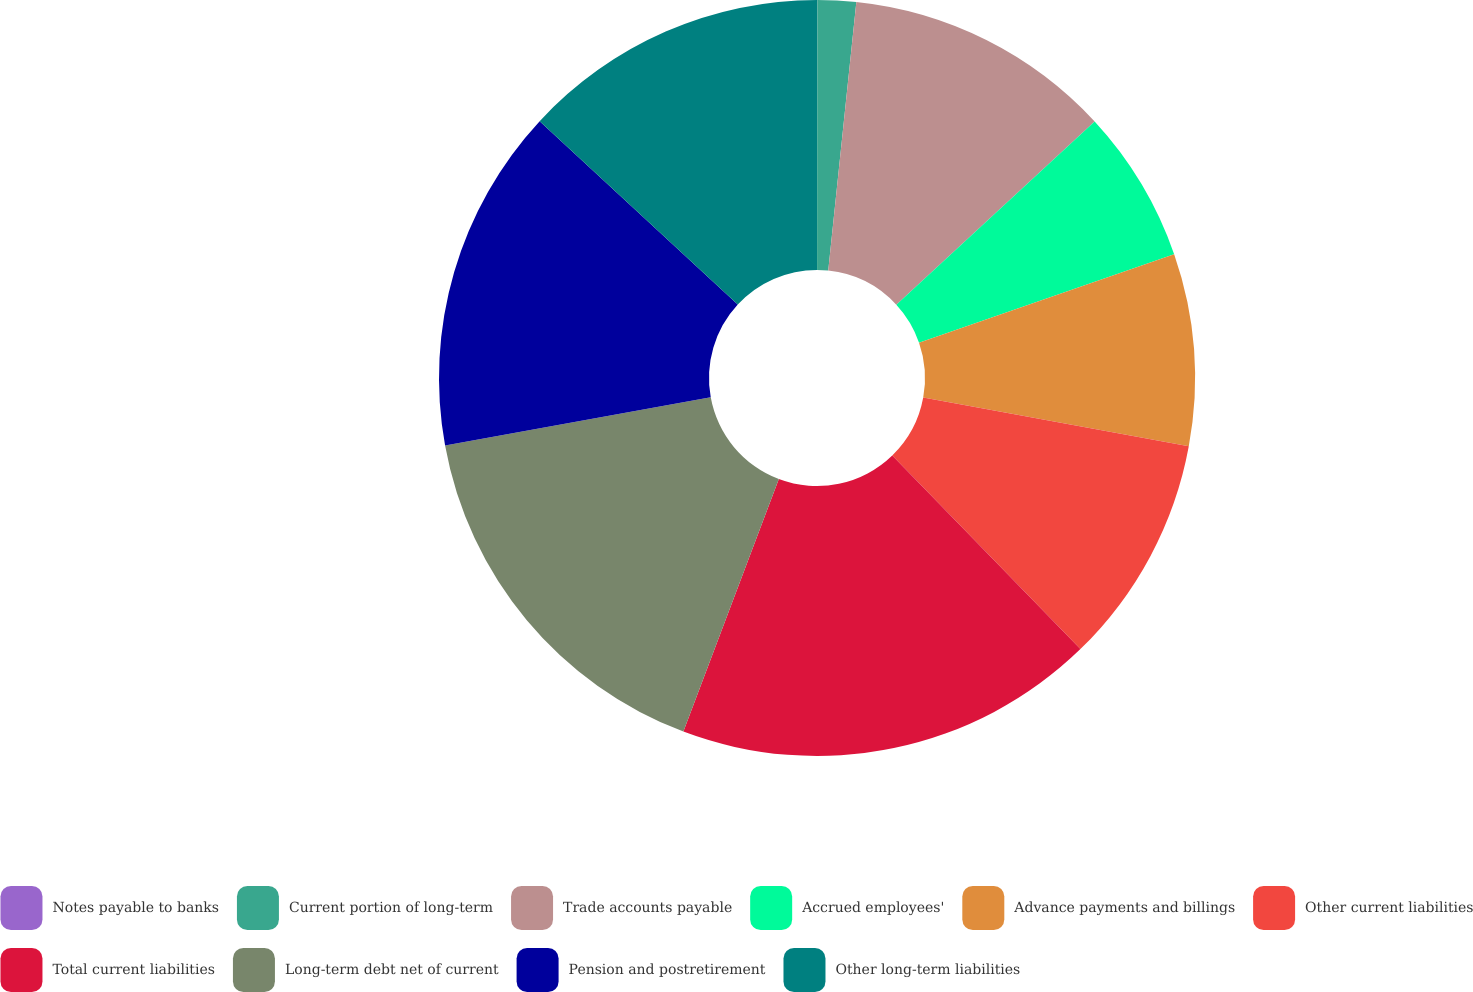Convert chart to OTSL. <chart><loc_0><loc_0><loc_500><loc_500><pie_chart><fcel>Notes payable to banks<fcel>Current portion of long-term<fcel>Trade accounts payable<fcel>Accrued employees'<fcel>Advance payments and billings<fcel>Other current liabilities<fcel>Total current liabilities<fcel>Long-term debt net of current<fcel>Pension and postretirement<fcel>Other long-term liabilities<nl><fcel>0.01%<fcel>1.65%<fcel>11.47%<fcel>6.56%<fcel>8.2%<fcel>9.84%<fcel>18.02%<fcel>16.39%<fcel>14.75%<fcel>13.11%<nl></chart> 